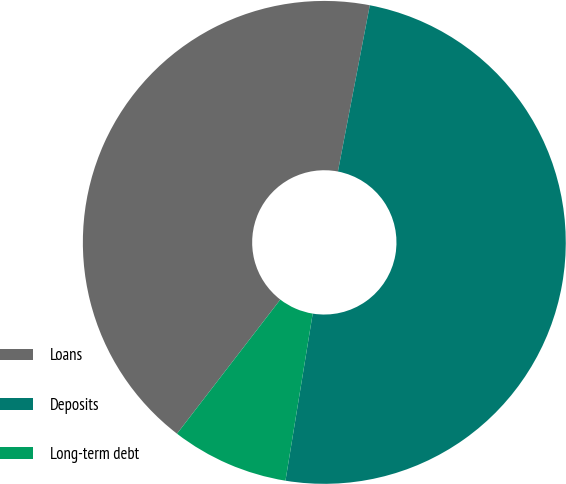Convert chart. <chart><loc_0><loc_0><loc_500><loc_500><pie_chart><fcel>Loans<fcel>Deposits<fcel>Long-term debt<nl><fcel>42.57%<fcel>49.55%<fcel>7.87%<nl></chart> 